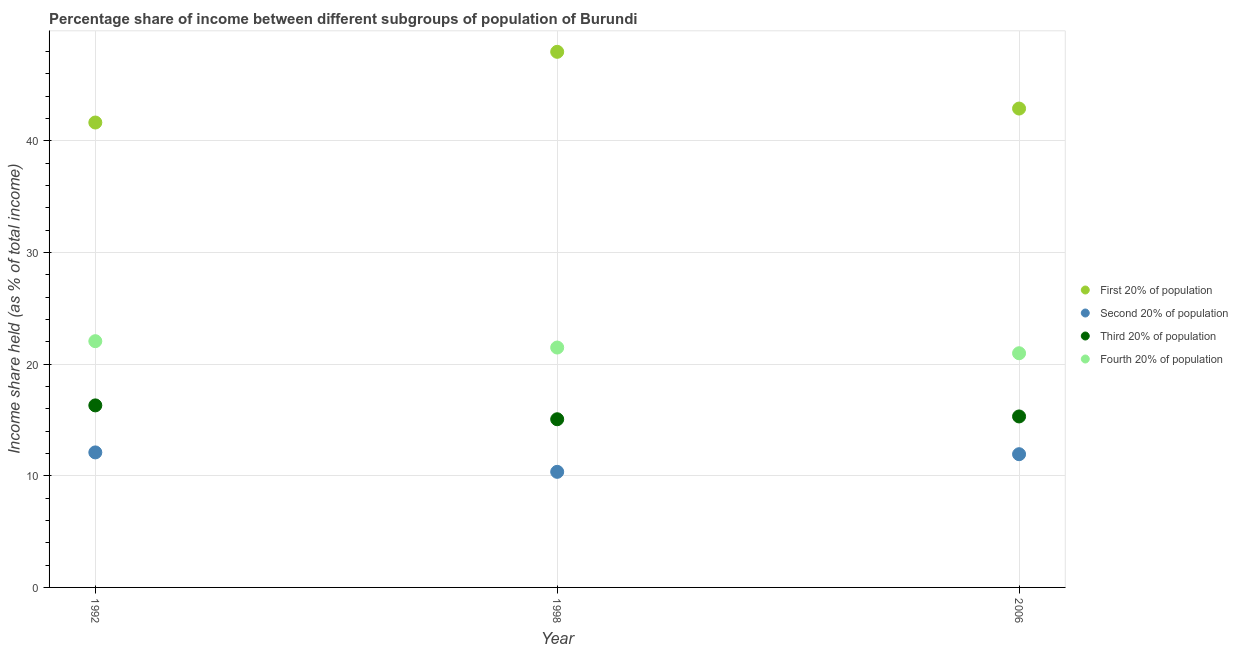How many different coloured dotlines are there?
Provide a short and direct response. 4. Is the number of dotlines equal to the number of legend labels?
Ensure brevity in your answer.  Yes. What is the share of the income held by second 20% of the population in 2006?
Provide a succinct answer. 11.93. Across all years, what is the maximum share of the income held by fourth 20% of the population?
Provide a succinct answer. 22.05. Across all years, what is the minimum share of the income held by third 20% of the population?
Keep it short and to the point. 15.06. What is the total share of the income held by second 20% of the population in the graph?
Make the answer very short. 34.37. What is the difference between the share of the income held by first 20% of the population in 1992 and that in 2006?
Keep it short and to the point. -1.25. What is the difference between the share of the income held by second 20% of the population in 2006 and the share of the income held by fourth 20% of the population in 1998?
Give a very brief answer. -9.55. What is the average share of the income held by first 20% of the population per year?
Provide a succinct answer. 44.16. In the year 1992, what is the difference between the share of the income held by fourth 20% of the population and share of the income held by second 20% of the population?
Make the answer very short. 9.96. In how many years, is the share of the income held by second 20% of the population greater than 30 %?
Give a very brief answer. 0. What is the ratio of the share of the income held by fourth 20% of the population in 1992 to that in 2006?
Provide a short and direct response. 1.05. What is the difference between the highest and the second highest share of the income held by second 20% of the population?
Offer a terse response. 0.16. What is the difference between the highest and the lowest share of the income held by first 20% of the population?
Offer a very short reply. 6.33. In how many years, is the share of the income held by fourth 20% of the population greater than the average share of the income held by fourth 20% of the population taken over all years?
Offer a terse response. 1. Is the sum of the share of the income held by fourth 20% of the population in 1992 and 1998 greater than the maximum share of the income held by third 20% of the population across all years?
Ensure brevity in your answer.  Yes. Does the share of the income held by first 20% of the population monotonically increase over the years?
Offer a terse response. No. Is the share of the income held by fourth 20% of the population strictly greater than the share of the income held by second 20% of the population over the years?
Provide a succinct answer. Yes. Is the share of the income held by first 20% of the population strictly less than the share of the income held by second 20% of the population over the years?
Ensure brevity in your answer.  No. How many dotlines are there?
Ensure brevity in your answer.  4. How many years are there in the graph?
Ensure brevity in your answer.  3. Does the graph contain any zero values?
Make the answer very short. No. Does the graph contain grids?
Provide a succinct answer. Yes. Where does the legend appear in the graph?
Your response must be concise. Center right. How are the legend labels stacked?
Make the answer very short. Vertical. What is the title of the graph?
Your answer should be compact. Percentage share of income between different subgroups of population of Burundi. What is the label or title of the X-axis?
Keep it short and to the point. Year. What is the label or title of the Y-axis?
Keep it short and to the point. Income share held (as % of total income). What is the Income share held (as % of total income) in First 20% of population in 1992?
Your answer should be very brief. 41.63. What is the Income share held (as % of total income) of Second 20% of population in 1992?
Offer a terse response. 12.09. What is the Income share held (as % of total income) of Third 20% of population in 1992?
Offer a very short reply. 16.3. What is the Income share held (as % of total income) of Fourth 20% of population in 1992?
Your answer should be compact. 22.05. What is the Income share held (as % of total income) of First 20% of population in 1998?
Your answer should be compact. 47.96. What is the Income share held (as % of total income) of Second 20% of population in 1998?
Your answer should be compact. 10.35. What is the Income share held (as % of total income) in Third 20% of population in 1998?
Make the answer very short. 15.06. What is the Income share held (as % of total income) of Fourth 20% of population in 1998?
Offer a terse response. 21.48. What is the Income share held (as % of total income) in First 20% of population in 2006?
Your answer should be compact. 42.88. What is the Income share held (as % of total income) in Second 20% of population in 2006?
Give a very brief answer. 11.93. What is the Income share held (as % of total income) of Third 20% of population in 2006?
Make the answer very short. 15.31. What is the Income share held (as % of total income) of Fourth 20% of population in 2006?
Give a very brief answer. 20.97. Across all years, what is the maximum Income share held (as % of total income) in First 20% of population?
Keep it short and to the point. 47.96. Across all years, what is the maximum Income share held (as % of total income) of Second 20% of population?
Your response must be concise. 12.09. Across all years, what is the maximum Income share held (as % of total income) of Third 20% of population?
Provide a succinct answer. 16.3. Across all years, what is the maximum Income share held (as % of total income) in Fourth 20% of population?
Provide a succinct answer. 22.05. Across all years, what is the minimum Income share held (as % of total income) of First 20% of population?
Your answer should be very brief. 41.63. Across all years, what is the minimum Income share held (as % of total income) of Second 20% of population?
Give a very brief answer. 10.35. Across all years, what is the minimum Income share held (as % of total income) in Third 20% of population?
Offer a very short reply. 15.06. Across all years, what is the minimum Income share held (as % of total income) of Fourth 20% of population?
Ensure brevity in your answer.  20.97. What is the total Income share held (as % of total income) of First 20% of population in the graph?
Give a very brief answer. 132.47. What is the total Income share held (as % of total income) of Second 20% of population in the graph?
Keep it short and to the point. 34.37. What is the total Income share held (as % of total income) in Third 20% of population in the graph?
Keep it short and to the point. 46.67. What is the total Income share held (as % of total income) in Fourth 20% of population in the graph?
Keep it short and to the point. 64.5. What is the difference between the Income share held (as % of total income) of First 20% of population in 1992 and that in 1998?
Your answer should be very brief. -6.33. What is the difference between the Income share held (as % of total income) of Second 20% of population in 1992 and that in 1998?
Offer a terse response. 1.74. What is the difference between the Income share held (as % of total income) of Third 20% of population in 1992 and that in 1998?
Your response must be concise. 1.24. What is the difference between the Income share held (as % of total income) of Fourth 20% of population in 1992 and that in 1998?
Make the answer very short. 0.57. What is the difference between the Income share held (as % of total income) in First 20% of population in 1992 and that in 2006?
Give a very brief answer. -1.25. What is the difference between the Income share held (as % of total income) in Second 20% of population in 1992 and that in 2006?
Your answer should be very brief. 0.16. What is the difference between the Income share held (as % of total income) in Third 20% of population in 1992 and that in 2006?
Offer a very short reply. 0.99. What is the difference between the Income share held (as % of total income) of First 20% of population in 1998 and that in 2006?
Offer a terse response. 5.08. What is the difference between the Income share held (as % of total income) in Second 20% of population in 1998 and that in 2006?
Give a very brief answer. -1.58. What is the difference between the Income share held (as % of total income) in Third 20% of population in 1998 and that in 2006?
Your response must be concise. -0.25. What is the difference between the Income share held (as % of total income) of Fourth 20% of population in 1998 and that in 2006?
Your response must be concise. 0.51. What is the difference between the Income share held (as % of total income) of First 20% of population in 1992 and the Income share held (as % of total income) of Second 20% of population in 1998?
Your answer should be very brief. 31.28. What is the difference between the Income share held (as % of total income) in First 20% of population in 1992 and the Income share held (as % of total income) in Third 20% of population in 1998?
Your response must be concise. 26.57. What is the difference between the Income share held (as % of total income) in First 20% of population in 1992 and the Income share held (as % of total income) in Fourth 20% of population in 1998?
Keep it short and to the point. 20.15. What is the difference between the Income share held (as % of total income) in Second 20% of population in 1992 and the Income share held (as % of total income) in Third 20% of population in 1998?
Offer a very short reply. -2.97. What is the difference between the Income share held (as % of total income) of Second 20% of population in 1992 and the Income share held (as % of total income) of Fourth 20% of population in 1998?
Your answer should be very brief. -9.39. What is the difference between the Income share held (as % of total income) in Third 20% of population in 1992 and the Income share held (as % of total income) in Fourth 20% of population in 1998?
Your response must be concise. -5.18. What is the difference between the Income share held (as % of total income) of First 20% of population in 1992 and the Income share held (as % of total income) of Second 20% of population in 2006?
Your response must be concise. 29.7. What is the difference between the Income share held (as % of total income) of First 20% of population in 1992 and the Income share held (as % of total income) of Third 20% of population in 2006?
Your answer should be compact. 26.32. What is the difference between the Income share held (as % of total income) of First 20% of population in 1992 and the Income share held (as % of total income) of Fourth 20% of population in 2006?
Your answer should be compact. 20.66. What is the difference between the Income share held (as % of total income) in Second 20% of population in 1992 and the Income share held (as % of total income) in Third 20% of population in 2006?
Provide a succinct answer. -3.22. What is the difference between the Income share held (as % of total income) in Second 20% of population in 1992 and the Income share held (as % of total income) in Fourth 20% of population in 2006?
Your response must be concise. -8.88. What is the difference between the Income share held (as % of total income) of Third 20% of population in 1992 and the Income share held (as % of total income) of Fourth 20% of population in 2006?
Ensure brevity in your answer.  -4.67. What is the difference between the Income share held (as % of total income) in First 20% of population in 1998 and the Income share held (as % of total income) in Second 20% of population in 2006?
Provide a short and direct response. 36.03. What is the difference between the Income share held (as % of total income) of First 20% of population in 1998 and the Income share held (as % of total income) of Third 20% of population in 2006?
Provide a short and direct response. 32.65. What is the difference between the Income share held (as % of total income) of First 20% of population in 1998 and the Income share held (as % of total income) of Fourth 20% of population in 2006?
Your response must be concise. 26.99. What is the difference between the Income share held (as % of total income) of Second 20% of population in 1998 and the Income share held (as % of total income) of Third 20% of population in 2006?
Provide a succinct answer. -4.96. What is the difference between the Income share held (as % of total income) in Second 20% of population in 1998 and the Income share held (as % of total income) in Fourth 20% of population in 2006?
Give a very brief answer. -10.62. What is the difference between the Income share held (as % of total income) of Third 20% of population in 1998 and the Income share held (as % of total income) of Fourth 20% of population in 2006?
Provide a short and direct response. -5.91. What is the average Income share held (as % of total income) in First 20% of population per year?
Offer a terse response. 44.16. What is the average Income share held (as % of total income) of Second 20% of population per year?
Ensure brevity in your answer.  11.46. What is the average Income share held (as % of total income) of Third 20% of population per year?
Offer a terse response. 15.56. What is the average Income share held (as % of total income) of Fourth 20% of population per year?
Keep it short and to the point. 21.5. In the year 1992, what is the difference between the Income share held (as % of total income) in First 20% of population and Income share held (as % of total income) in Second 20% of population?
Offer a terse response. 29.54. In the year 1992, what is the difference between the Income share held (as % of total income) in First 20% of population and Income share held (as % of total income) in Third 20% of population?
Ensure brevity in your answer.  25.33. In the year 1992, what is the difference between the Income share held (as % of total income) in First 20% of population and Income share held (as % of total income) in Fourth 20% of population?
Give a very brief answer. 19.58. In the year 1992, what is the difference between the Income share held (as % of total income) of Second 20% of population and Income share held (as % of total income) of Third 20% of population?
Make the answer very short. -4.21. In the year 1992, what is the difference between the Income share held (as % of total income) of Second 20% of population and Income share held (as % of total income) of Fourth 20% of population?
Make the answer very short. -9.96. In the year 1992, what is the difference between the Income share held (as % of total income) in Third 20% of population and Income share held (as % of total income) in Fourth 20% of population?
Your response must be concise. -5.75. In the year 1998, what is the difference between the Income share held (as % of total income) of First 20% of population and Income share held (as % of total income) of Second 20% of population?
Provide a short and direct response. 37.61. In the year 1998, what is the difference between the Income share held (as % of total income) in First 20% of population and Income share held (as % of total income) in Third 20% of population?
Offer a very short reply. 32.9. In the year 1998, what is the difference between the Income share held (as % of total income) of First 20% of population and Income share held (as % of total income) of Fourth 20% of population?
Make the answer very short. 26.48. In the year 1998, what is the difference between the Income share held (as % of total income) in Second 20% of population and Income share held (as % of total income) in Third 20% of population?
Offer a terse response. -4.71. In the year 1998, what is the difference between the Income share held (as % of total income) of Second 20% of population and Income share held (as % of total income) of Fourth 20% of population?
Provide a succinct answer. -11.13. In the year 1998, what is the difference between the Income share held (as % of total income) in Third 20% of population and Income share held (as % of total income) in Fourth 20% of population?
Provide a short and direct response. -6.42. In the year 2006, what is the difference between the Income share held (as % of total income) of First 20% of population and Income share held (as % of total income) of Second 20% of population?
Ensure brevity in your answer.  30.95. In the year 2006, what is the difference between the Income share held (as % of total income) in First 20% of population and Income share held (as % of total income) in Third 20% of population?
Your answer should be very brief. 27.57. In the year 2006, what is the difference between the Income share held (as % of total income) in First 20% of population and Income share held (as % of total income) in Fourth 20% of population?
Your answer should be compact. 21.91. In the year 2006, what is the difference between the Income share held (as % of total income) of Second 20% of population and Income share held (as % of total income) of Third 20% of population?
Offer a terse response. -3.38. In the year 2006, what is the difference between the Income share held (as % of total income) in Second 20% of population and Income share held (as % of total income) in Fourth 20% of population?
Keep it short and to the point. -9.04. In the year 2006, what is the difference between the Income share held (as % of total income) in Third 20% of population and Income share held (as % of total income) in Fourth 20% of population?
Provide a succinct answer. -5.66. What is the ratio of the Income share held (as % of total income) in First 20% of population in 1992 to that in 1998?
Your response must be concise. 0.87. What is the ratio of the Income share held (as % of total income) of Second 20% of population in 1992 to that in 1998?
Provide a succinct answer. 1.17. What is the ratio of the Income share held (as % of total income) in Third 20% of population in 1992 to that in 1998?
Offer a very short reply. 1.08. What is the ratio of the Income share held (as % of total income) in Fourth 20% of population in 1992 to that in 1998?
Offer a very short reply. 1.03. What is the ratio of the Income share held (as % of total income) of First 20% of population in 1992 to that in 2006?
Your answer should be very brief. 0.97. What is the ratio of the Income share held (as % of total income) in Second 20% of population in 1992 to that in 2006?
Your answer should be compact. 1.01. What is the ratio of the Income share held (as % of total income) of Third 20% of population in 1992 to that in 2006?
Ensure brevity in your answer.  1.06. What is the ratio of the Income share held (as % of total income) in Fourth 20% of population in 1992 to that in 2006?
Offer a terse response. 1.05. What is the ratio of the Income share held (as % of total income) of First 20% of population in 1998 to that in 2006?
Give a very brief answer. 1.12. What is the ratio of the Income share held (as % of total income) in Second 20% of population in 1998 to that in 2006?
Make the answer very short. 0.87. What is the ratio of the Income share held (as % of total income) of Third 20% of population in 1998 to that in 2006?
Keep it short and to the point. 0.98. What is the ratio of the Income share held (as % of total income) in Fourth 20% of population in 1998 to that in 2006?
Provide a succinct answer. 1.02. What is the difference between the highest and the second highest Income share held (as % of total income) of First 20% of population?
Offer a terse response. 5.08. What is the difference between the highest and the second highest Income share held (as % of total income) in Second 20% of population?
Keep it short and to the point. 0.16. What is the difference between the highest and the second highest Income share held (as % of total income) in Third 20% of population?
Ensure brevity in your answer.  0.99. What is the difference between the highest and the second highest Income share held (as % of total income) in Fourth 20% of population?
Offer a terse response. 0.57. What is the difference between the highest and the lowest Income share held (as % of total income) of First 20% of population?
Ensure brevity in your answer.  6.33. What is the difference between the highest and the lowest Income share held (as % of total income) of Second 20% of population?
Offer a terse response. 1.74. What is the difference between the highest and the lowest Income share held (as % of total income) of Third 20% of population?
Offer a very short reply. 1.24. What is the difference between the highest and the lowest Income share held (as % of total income) in Fourth 20% of population?
Offer a terse response. 1.08. 